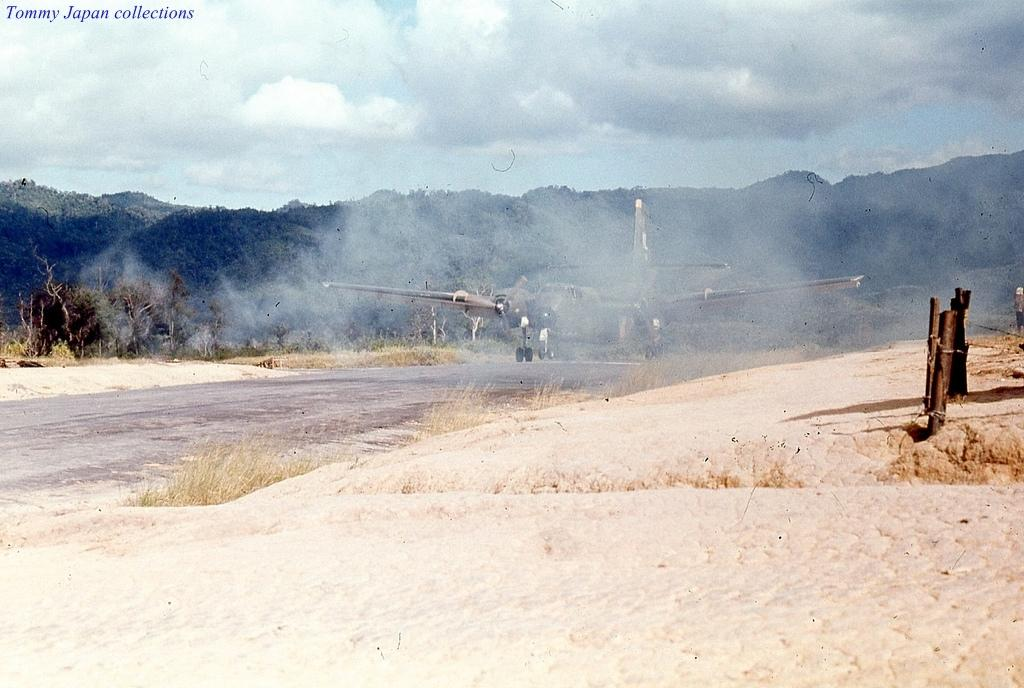What type of terrain is visible in the image? There is sand and grass visible in the image. What is the unusual object located on the road in the image? There is an airplane on the road in the image. What can be seen in the background of the image? There are trees, smoke, and clouds visible in the background. What type of learning activity is taking place in the image? There is no learning activity present in the image. Can you see a bear in the image? There is no bear present in the image. 